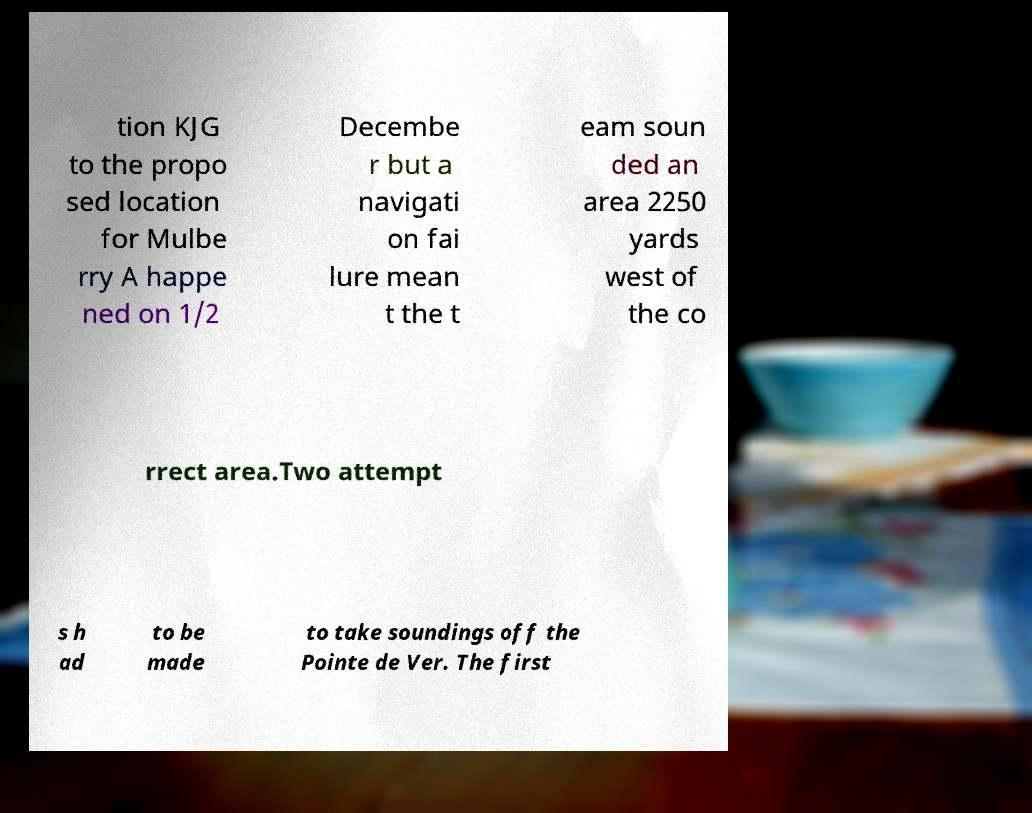I need the written content from this picture converted into text. Can you do that? tion KJG to the propo sed location for Mulbe rry A happe ned on 1/2 Decembe r but a navigati on fai lure mean t the t eam soun ded an area 2250 yards west of the co rrect area.Two attempt s h ad to be made to take soundings off the Pointe de Ver. The first 